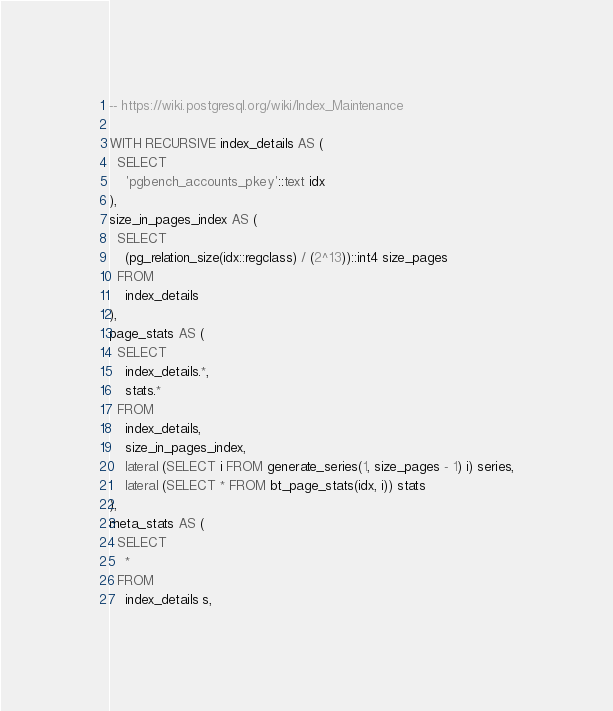Convert code to text. <code><loc_0><loc_0><loc_500><loc_500><_SQL_>-- https://wiki.postgresql.org/wiki/Index_Maintenance

WITH RECURSIVE index_details AS (
  SELECT
    'pgbench_accounts_pkey'::text idx
),
size_in_pages_index AS (
  SELECT
    (pg_relation_size(idx::regclass) / (2^13))::int4 size_pages
  FROM
    index_details
),
page_stats AS (
  SELECT
    index_details.*,
    stats.*
  FROM
    index_details,
    size_in_pages_index,
    lateral (SELECT i FROM generate_series(1, size_pages - 1) i) series,
    lateral (SELECT * FROM bt_page_stats(idx, i)) stats
),
meta_stats AS (
  SELECT
    *
  FROM
    index_details s,</code> 